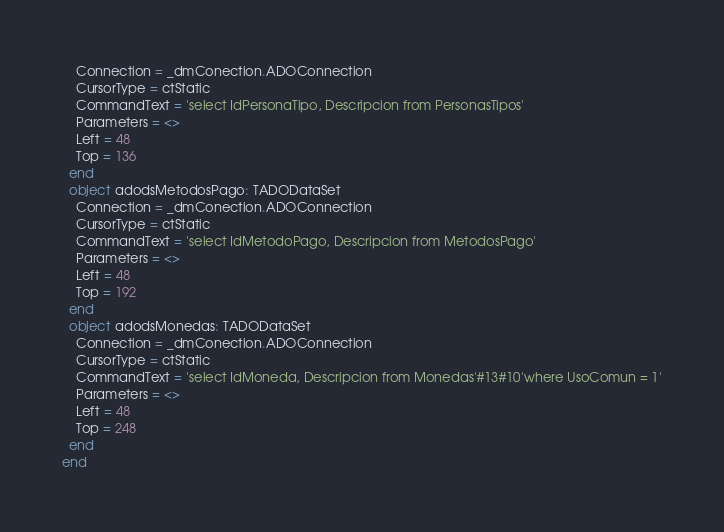<code> <loc_0><loc_0><loc_500><loc_500><_Pascal_>    Connection = _dmConection.ADOConnection
    CursorType = ctStatic
    CommandText = 'select IdPersonaTipo, Descripcion from PersonasTipos'
    Parameters = <>
    Left = 48
    Top = 136
  end
  object adodsMetodosPago: TADODataSet
    Connection = _dmConection.ADOConnection
    CursorType = ctStatic
    CommandText = 'select IdMetodoPago, Descripcion from MetodosPago'
    Parameters = <>
    Left = 48
    Top = 192
  end
  object adodsMonedas: TADODataSet
    Connection = _dmConection.ADOConnection
    CursorType = ctStatic
    CommandText = 'select IdMoneda, Descripcion from Monedas'#13#10'where UsoComun = 1'
    Parameters = <>
    Left = 48
    Top = 248
  end
end
</code> 